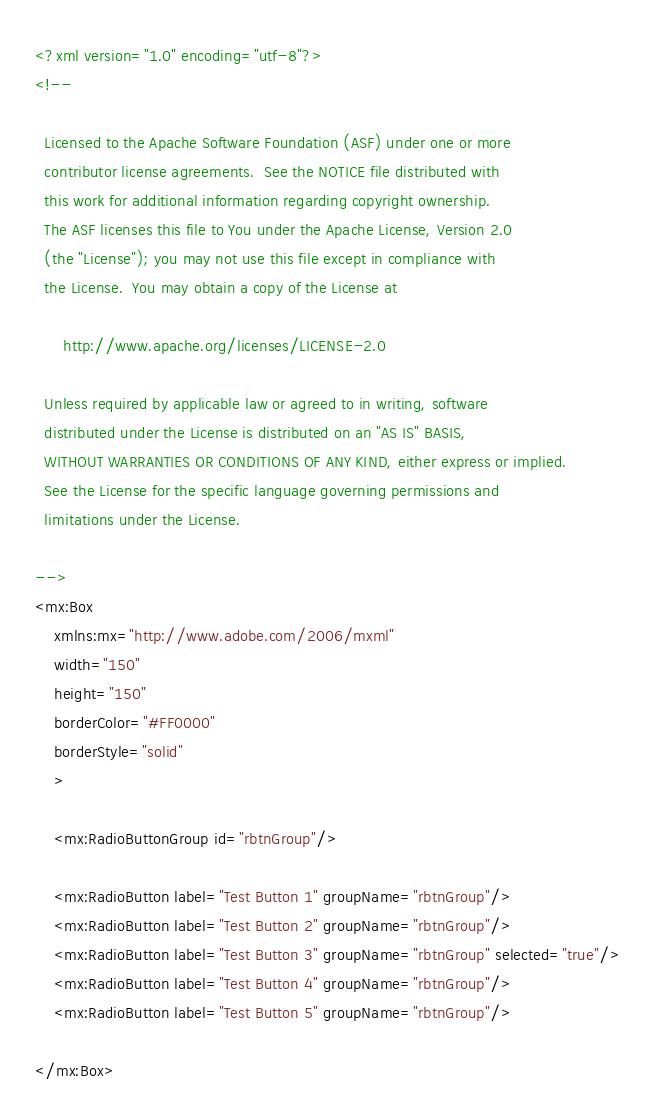Convert code to text. <code><loc_0><loc_0><loc_500><loc_500><_XML_><?xml version="1.0" encoding="utf-8"?>
<!--

  Licensed to the Apache Software Foundation (ASF) under one or more
  contributor license agreements.  See the NOTICE file distributed with
  this work for additional information regarding copyright ownership.
  The ASF licenses this file to You under the Apache License, Version 2.0
  (the "License"); you may not use this file except in compliance with
  the License.  You may obtain a copy of the License at

      http://www.apache.org/licenses/LICENSE-2.0

  Unless required by applicable law or agreed to in writing, software
  distributed under the License is distributed on an "AS IS" BASIS,
  WITHOUT WARRANTIES OR CONDITIONS OF ANY KIND, either express or implied.
  See the License for the specific language governing permissions and
  limitations under the License.

-->
<mx:Box 
	xmlns:mx="http://www.adobe.com/2006/mxml" 
	width="150" 
	height="150" 
	borderColor="#FF0000" 
	borderStyle="solid" 
	>

	<mx:RadioButtonGroup id="rbtnGroup"/>

	<mx:RadioButton label="Test Button 1" groupName="rbtnGroup"/>
	<mx:RadioButton label="Test Button 2" groupName="rbtnGroup"/>
	<mx:RadioButton label="Test Button 3" groupName="rbtnGroup" selected="true"/>
	<mx:RadioButton label="Test Button 4" groupName="rbtnGroup"/>
	<mx:RadioButton label="Test Button 5" groupName="rbtnGroup"/>
	
</mx:Box>
</code> 